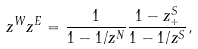Convert formula to latex. <formula><loc_0><loc_0><loc_500><loc_500>z ^ { W } z ^ { E } = \frac { 1 } { 1 - 1 / z ^ { N } } \frac { 1 - z ^ { S } _ { + } } { 1 - 1 / z ^ { S } } ,</formula> 